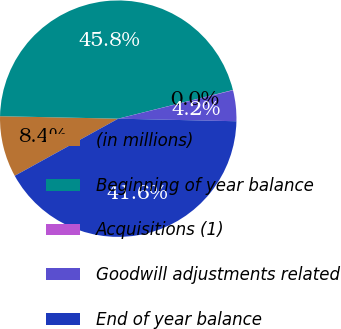Convert chart. <chart><loc_0><loc_0><loc_500><loc_500><pie_chart><fcel>(in millions)<fcel>Beginning of year balance<fcel>Acquisitions (1)<fcel>Goodwill adjustments related<fcel>End of year balance<nl><fcel>8.36%<fcel>45.77%<fcel>0.04%<fcel>4.2%<fcel>41.62%<nl></chart> 